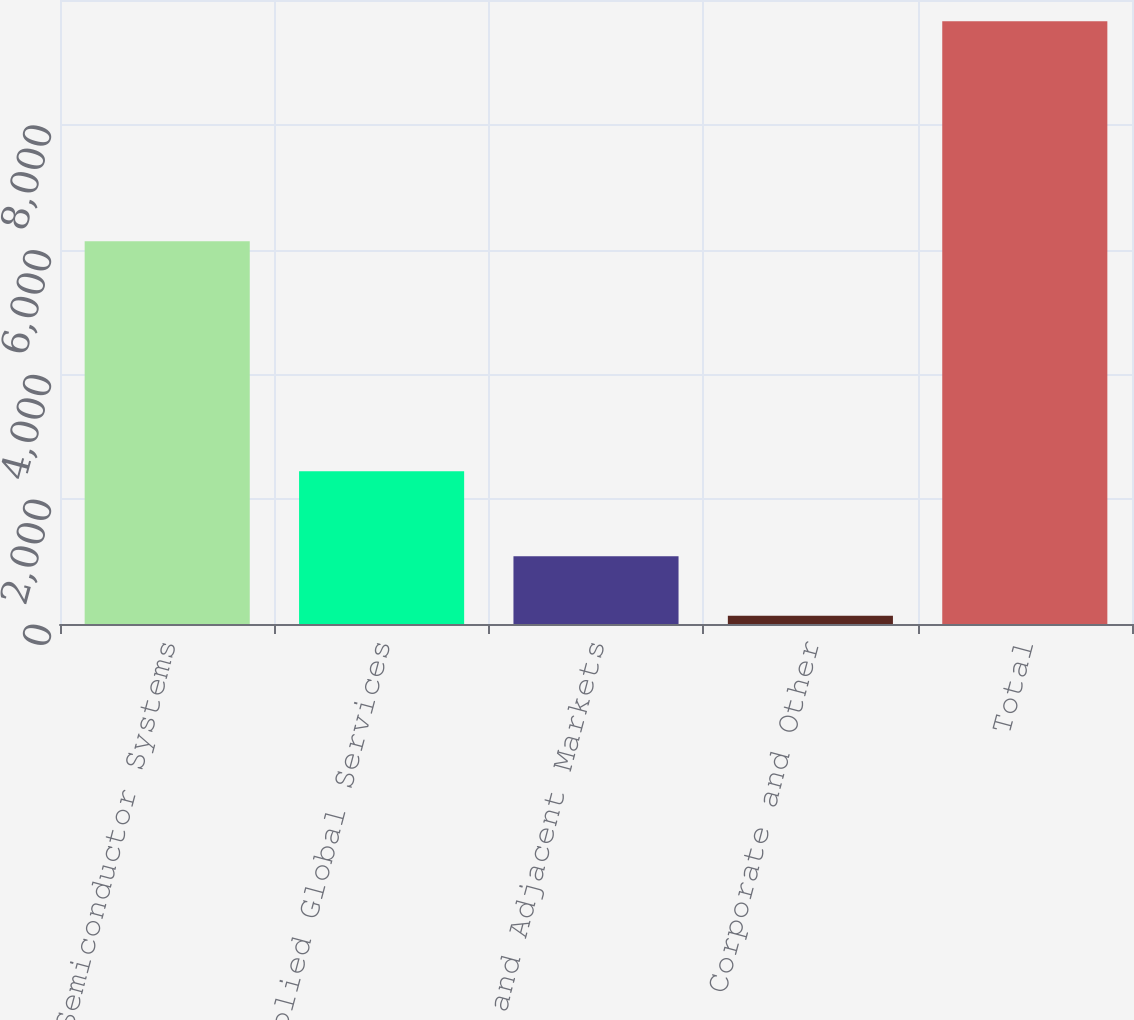Convert chart to OTSL. <chart><loc_0><loc_0><loc_500><loc_500><bar_chart><fcel>Semiconductor Systems<fcel>Applied Global Services<fcel>Display and Adjacent Markets<fcel>Corporate and Other<fcel>Total<nl><fcel>6135<fcel>2447<fcel>1085.6<fcel>133<fcel>9659<nl></chart> 